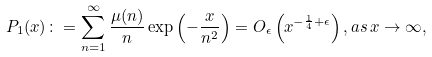Convert formula to latex. <formula><loc_0><loc_0><loc_500><loc_500>P _ { 1 } ( x ) \colon = \sum _ { n = 1 } ^ { \infty } \frac { \mu ( n ) } { n } \exp \left ( { - \frac { x } { n ^ { 2 } } } \right ) = O _ { \epsilon } \left ( x ^ { - \frac { 1 } { 4 } + \epsilon } \right ) , a s \, x \rightarrow \infty ,</formula> 